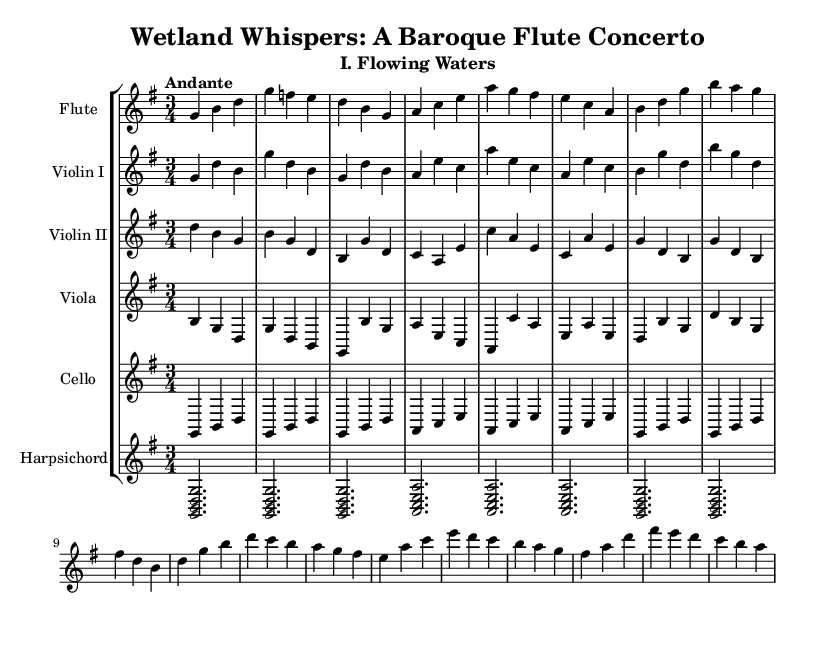What is the key signature of this music? The key signature is G major, which has one sharp (F#). This can be identified by looking for the sharps indicated at the beginning of the staff.
Answer: G major What is the time signature of this music? The time signature is 3/4, which means there are three beats per measure and a quarter note gets one beat. This is shown at the beginning of the piece.
Answer: 3/4 What is the tempo marking of the piece? The tempo marking is Andante, which suggests a moderately slow tempo. This is explicitly stated in the tempo indication at the beginning of the score.
Answer: Andante How many measures are in the flute part? There are 16 measures in the flute part, which can be counted by visually scanning the notes and bar lines in the flute staff.
Answer: 16 Which instrument has the highest pitch in this score? The flute typically plays the highest pitch given its range and the notated notes. By comparing the highest notes in each part, the flute consistently occupies the upper range.
Answer: Flute What type of musical form is likely used in this concerto? The concerto likely uses a ritornello form, typical of the Baroque era, where a recurring theme is interspersed with contrasting episodes. This can be inferred from the structure and thematic presentation, although it is not explicitly notated.
Answer: Ritornello What dynamic markings are present in the music? The music does not contain specific dynamic markings in the provided excerpt; however, dynamics can often be implied through phrasing and the expressive style of the Baroque period.
Answer: None explicitly stated 